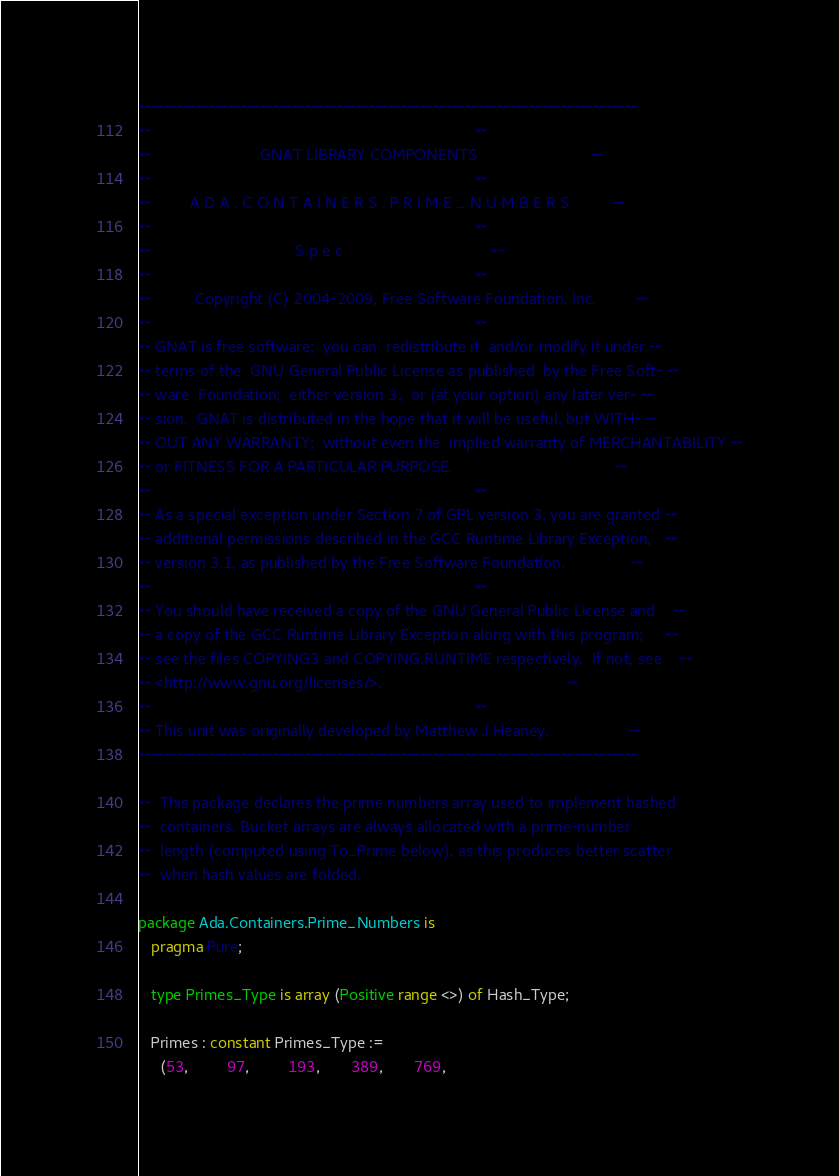<code> <loc_0><loc_0><loc_500><loc_500><_Ada_>------------------------------------------------------------------------------
--                                                                          --
--                         GNAT LIBRARY COMPONENTS                          --
--                                                                          --
--         A D A . C O N T A I N E R S . P R I M E _ N U M B E R S          --
--                                                                          --
--                                 S p e c                                  --
--                                                                          --
--          Copyright (C) 2004-2009, Free Software Foundation, Inc.         --
--                                                                          --
-- GNAT is free software;  you can  redistribute it  and/or modify it under --
-- terms of the  GNU General Public License as published  by the Free Soft- --
-- ware  Foundation;  either version 3,  or (at your option) any later ver- --
-- sion.  GNAT is distributed in the hope that it will be useful, but WITH- --
-- OUT ANY WARRANTY;  without even the  implied warranty of MERCHANTABILITY --
-- or FITNESS FOR A PARTICULAR PURPOSE.                                     --
--                                                                          --
-- As a special exception under Section 7 of GPL version 3, you are granted --
-- additional permissions described in the GCC Runtime Library Exception,   --
-- version 3.1, as published by the Free Software Foundation.               --
--                                                                          --
-- You should have received a copy of the GNU General Public License and    --
-- a copy of the GCC Runtime Library Exception along with this program;     --
-- see the files COPYING3 and COPYING.RUNTIME respectively.  If not, see    --
-- <http://www.gnu.org/licenses/>.                                          --
--                                                                          --
-- This unit was originally developed by Matthew J Heaney.                  --
------------------------------------------------------------------------------

--  This package declares the prime numbers array used to implement hashed
--  containers. Bucket arrays are always allocated with a prime-number
--  length (computed using To_Prime below), as this produces better scatter
--  when hash values are folded.

package Ada.Containers.Prime_Numbers is
   pragma Pure;

   type Primes_Type is array (Positive range <>) of Hash_Type;

   Primes : constant Primes_Type :=
     (53,         97,         193,       389,       769,</code> 